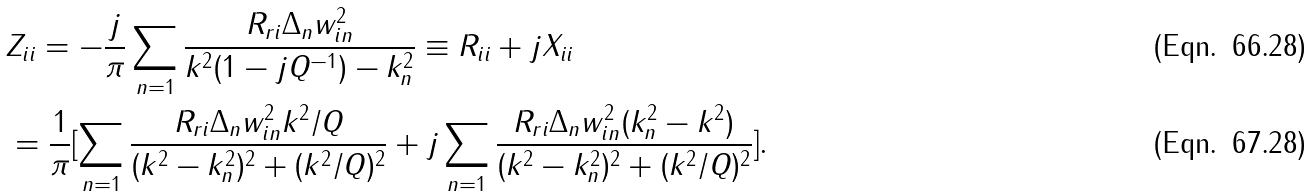<formula> <loc_0><loc_0><loc_500><loc_500>& Z _ { i i } = - \frac { j } { \pi } \sum _ { n = 1 } \frac { R _ { r i } \Delta _ { n } w _ { i n } ^ { 2 } } { k ^ { 2 } ( 1 - j Q ^ { - 1 } ) - k _ { n } ^ { 2 } } \equiv R _ { i i } + j X _ { i i } \\ & = \frac { 1 } { \pi } [ \sum _ { n = 1 } \frac { R _ { r i } \Delta _ { n } w _ { i n } ^ { 2 } k ^ { 2 } / Q } { ( k ^ { 2 } - k _ { n } ^ { 2 } ) ^ { 2 } + ( k ^ { 2 } / Q ) ^ { 2 } } + j \sum _ { n = 1 } \frac { R _ { r i } \Delta _ { n } w _ { i n } ^ { 2 } ( k _ { n } ^ { 2 } - k ^ { 2 } ) } { ( k ^ { 2 } - k _ { n } ^ { 2 } ) ^ { 2 } + ( k ^ { 2 } / Q ) ^ { 2 } } ] .</formula> 